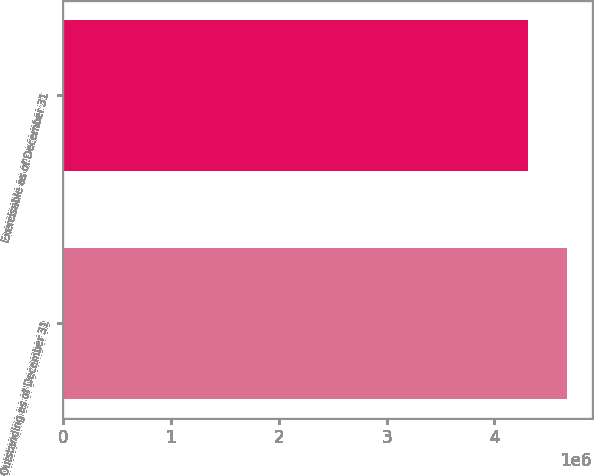<chart> <loc_0><loc_0><loc_500><loc_500><bar_chart><fcel>Outstanding as of December 31<fcel>Exercisable as of December 31<nl><fcel>4.66922e+06<fcel>4.31541e+06<nl></chart> 